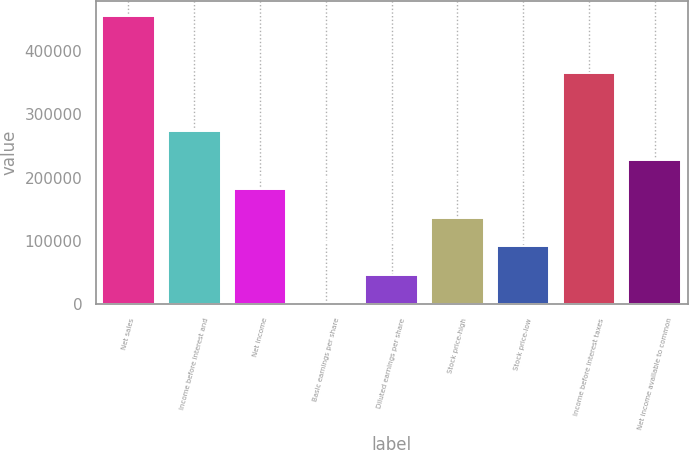Convert chart to OTSL. <chart><loc_0><loc_0><loc_500><loc_500><bar_chart><fcel>Net sales<fcel>Income before interest and<fcel>Net income<fcel>Basic earnings per share<fcel>Diluted earnings per share<fcel>Stock price-high<fcel>Stock price-low<fcel>Income before interest taxes<fcel>Net income available to common<nl><fcel>455570<fcel>273342<fcel>182228<fcel>0.14<fcel>45557.1<fcel>136671<fcel>91114.1<fcel>364456<fcel>227785<nl></chart> 